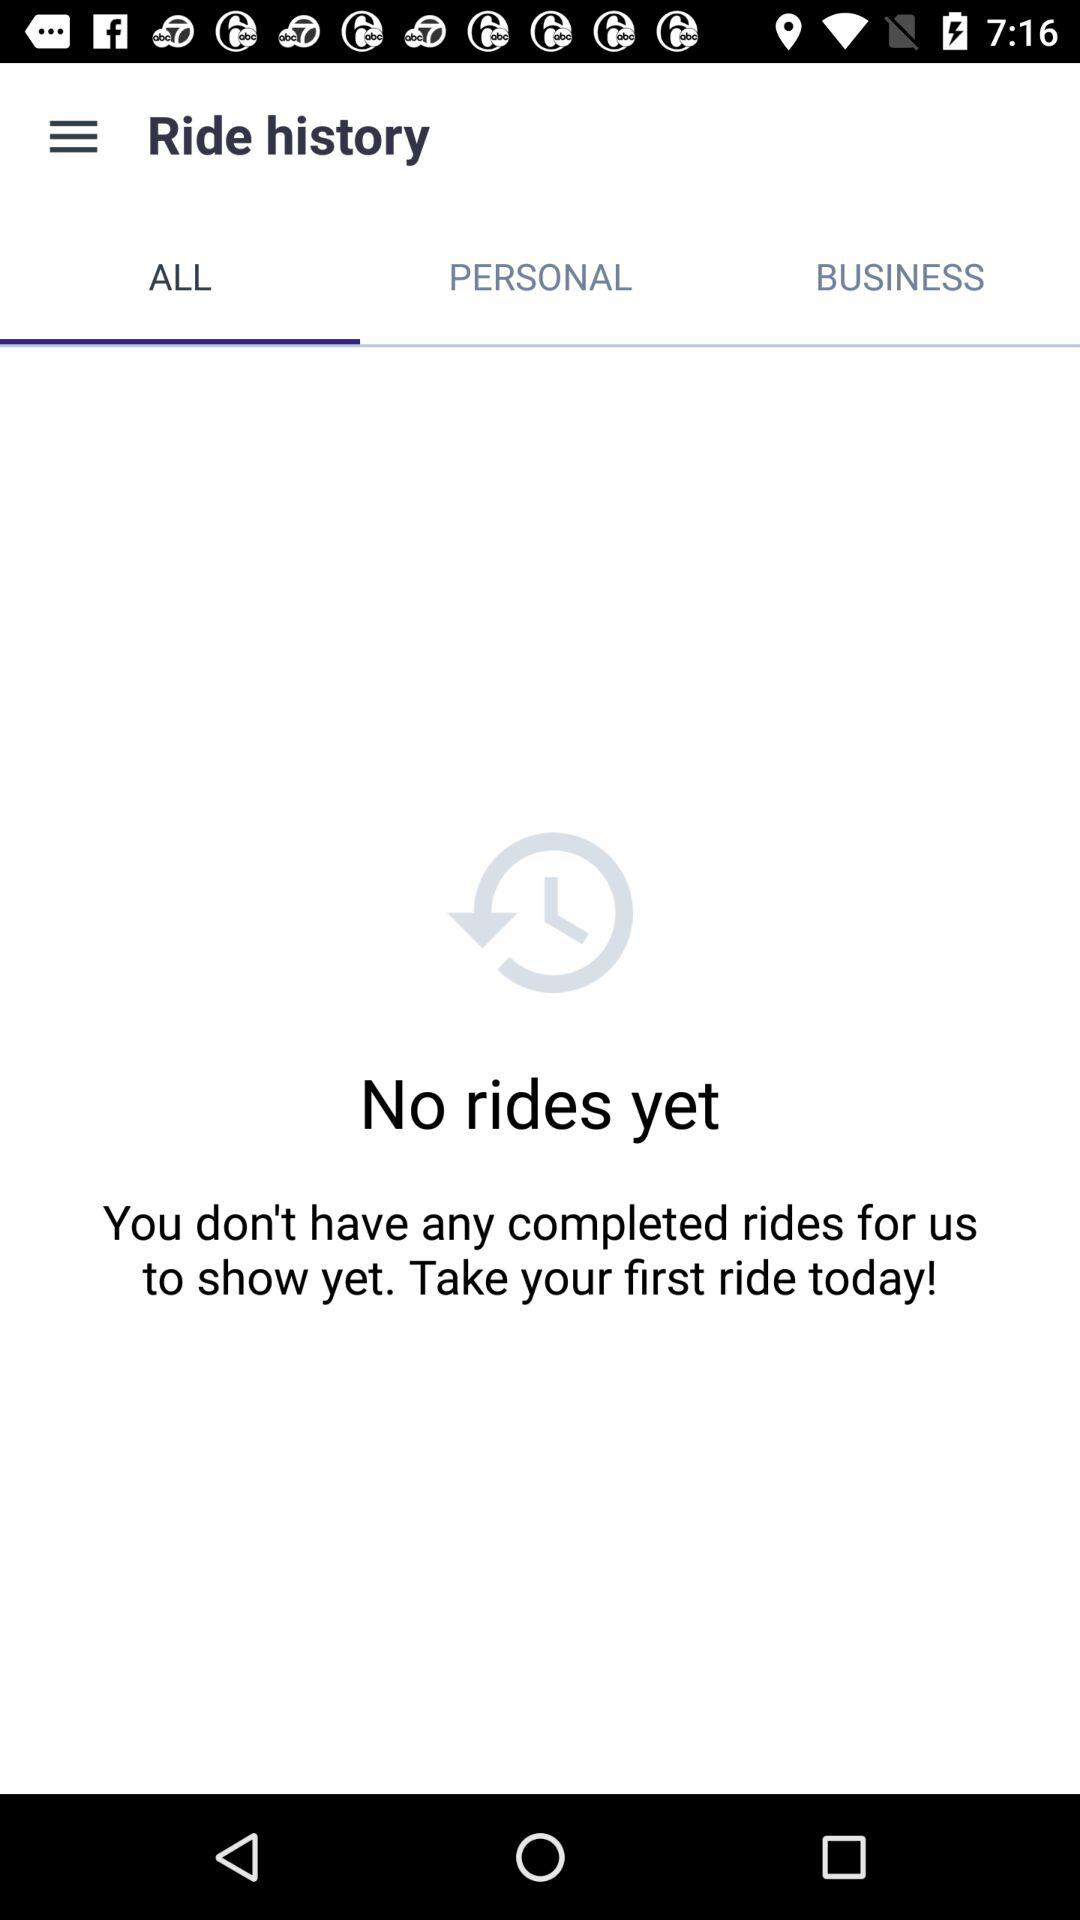Which tab is selected? The selected tab is "ALL". 